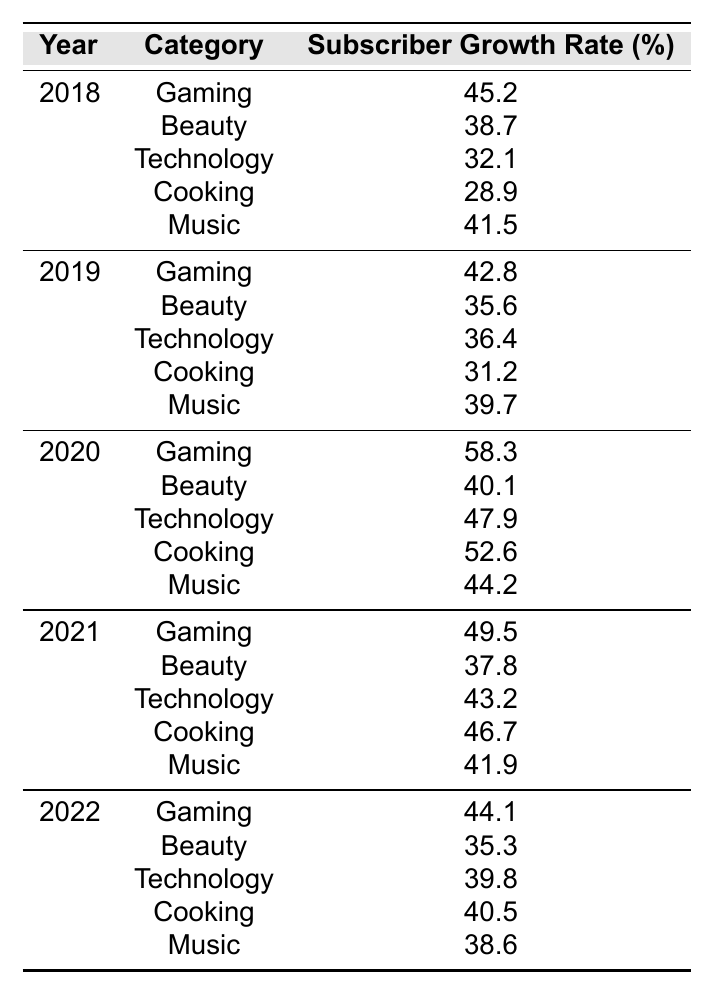What was the subscriber growth rate for the Cooking category in 2020? The table shows that in 2020, the subscriber growth rate for the Cooking category is 52.6%.
Answer: 52.6 Which year had the highest subscriber growth rate for the Music category? By looking at the Music category in the table, the highest growth rate is in 2020 at 44.2%.
Answer: 2020 What was the average subscriber growth rate for the Beauty category from 2018 to 2022? Summing the growth rates for Beauty over the years gives (38.7 + 35.6 + 40.1 + 37.8 + 35.3) = 187.5. There are 5 years, so the average is 187.5 / 5 = 37.5.
Answer: 37.5 Did the Gaming category see a decline in subscriber growth rate from 2018 to 2022? By examining the values for the Gaming category, we see that the growth rates were 45.2 in 2018, 42.8 in 2019, 58.3 in 2020, 49.5 in 2021, and 44.1 in 2022. Notably, after increasing in 2020, there’s a decline in 2022 compared to the previous year.
Answer: Yes What was the difference in subscriber growth rates for the Technology category between 2018 and 2020? The subscriber growth rate for Technology in 2018 is 32.1%, and in 2020 it is 47.9%. The difference is 47.9 - 32.1 = 15.8%.
Answer: 15.8 Which content category had the lowest average subscriber growth rate from 2018 to 2022? To find the lowest average, we calculate each category's average. The averages are as follows: Gaming (45.8), Beauty (37.5), Technology (43.4), Cooking (39.5), Music (38.6). The lowest is Beauty with 37.5.
Answer: Beauty In which year did the Cooking category experience the highest subscriber growth rate? The highest growth rate for Cooking is in 2020 at 52.6%. The other years are lower than this value.
Answer: 2020 True or False: The subscriber growth rate for Gaming was consistently above 40% from 2018 to 2022. Reviewing the data, Gaming had rates of 45.2 (2018), 42.8 (2019), 58.3 (2020), 49.5 (2021), and 44.1 (2022), all above 40%.
Answer: True What is the total subscriber growth rate for all categories in 2019? Summing all the subscriber growth rates for 2019 gives (42.8 + 35.6 + 36.4 + 31.2 + 39.7) = 185.7.
Answer: 185.7 Which content category saw the most significant increase in subscriber growth rate from 2019 to 2020? Comparing rates, Gaming increased from 42.8 in 2019 to 58.3 in 2020, a change of 15.5%. This is the largest increase among all categories.
Answer: Gaming 